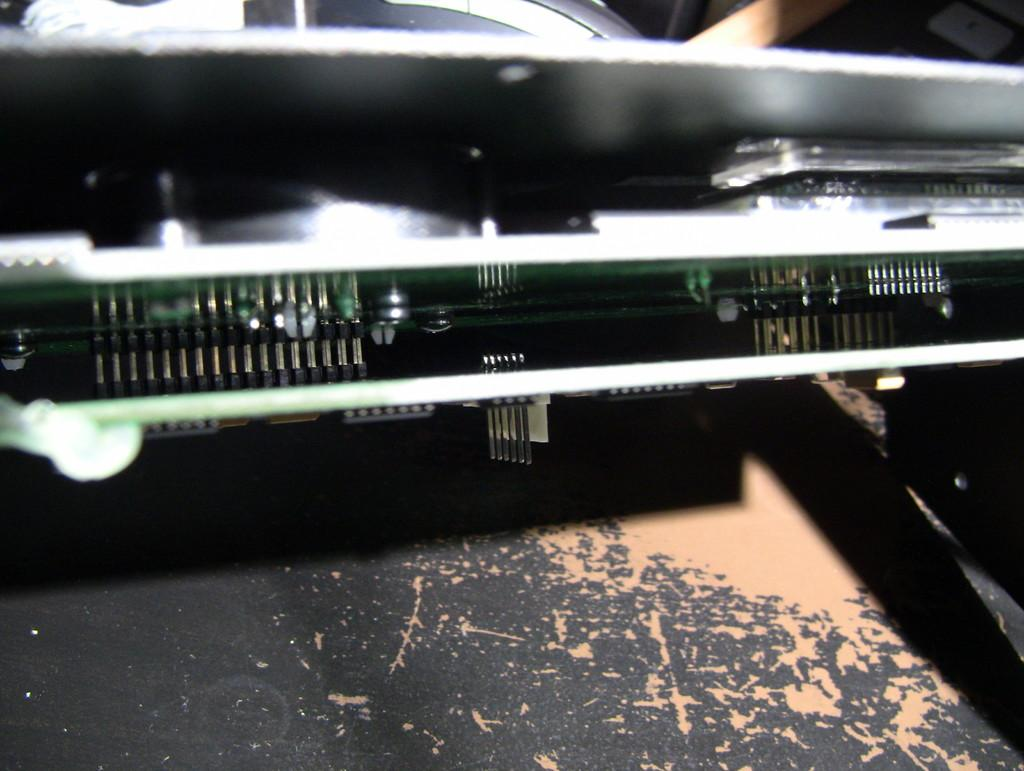What type of furniture is present in the image? There is a table in the image. Where is the table located in the image? The table is at the bottom of the image. What can be seen on top of the table? There is a metal object on the table. How many family members are present in the image? There is no information about family members in the image, as it only features a table with a metal object on it. Can you see any snails crawling on the table in the image? There are no snails present in the image; it only features a table with a metal object on it. 